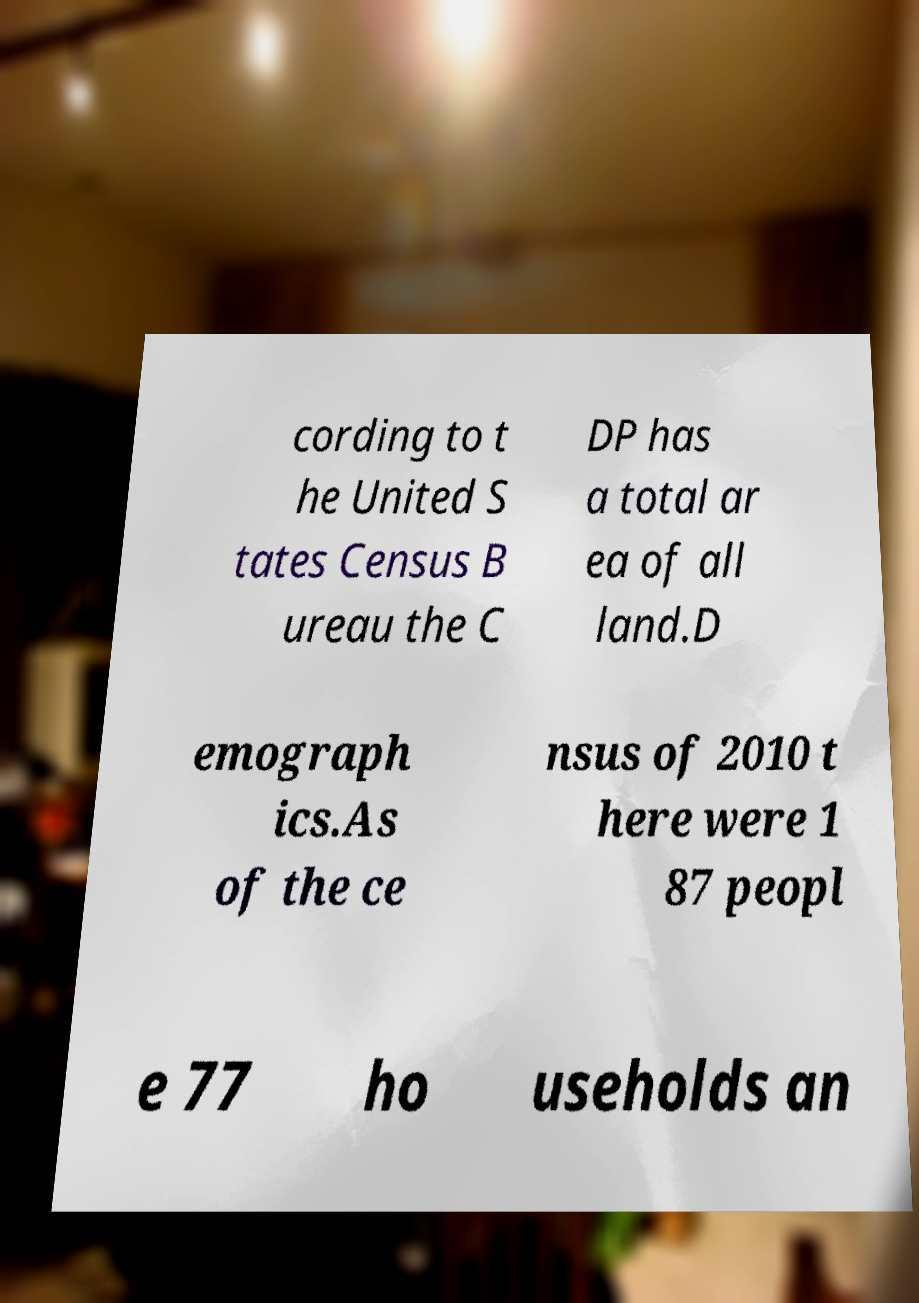I need the written content from this picture converted into text. Can you do that? cording to t he United S tates Census B ureau the C DP has a total ar ea of all land.D emograph ics.As of the ce nsus of 2010 t here were 1 87 peopl e 77 ho useholds an 